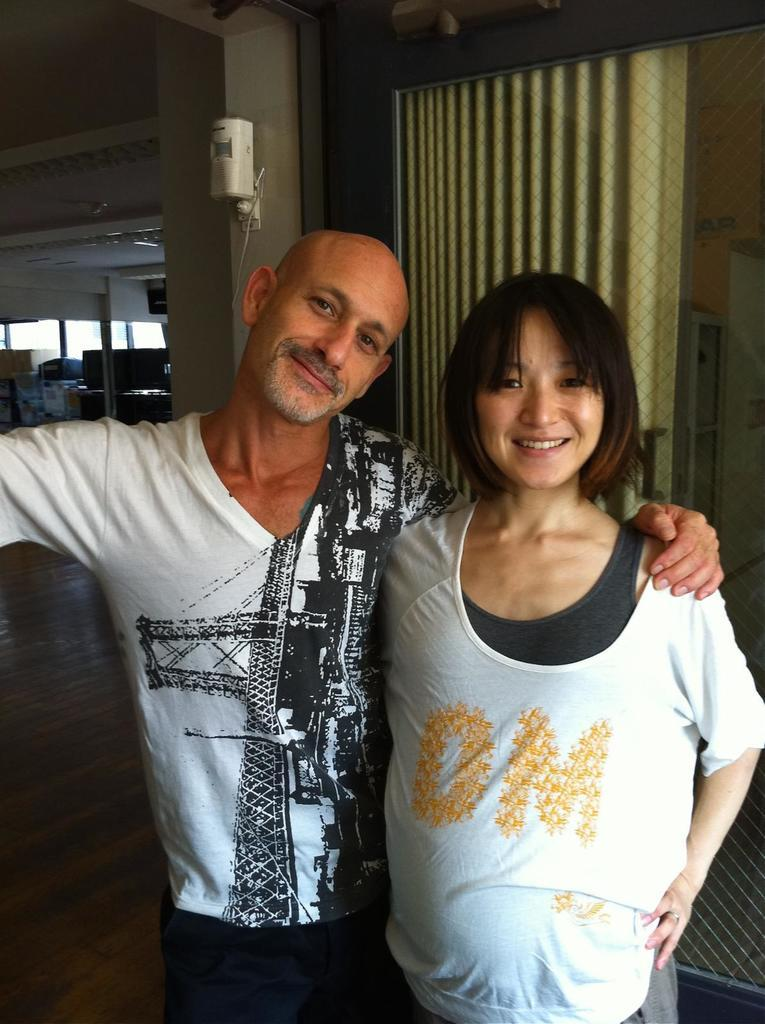How many people are present in the image? There are two people, a man and a woman, present in the image. What are the man and woman wearing? Both the man and woman are wearing white t-shirts. What can be seen in the background of the image? There is a curtain in the image. What color is the white object in the image? The white object in the image is white. How many sticks are being used by the man and woman in the image? There are no sticks present in the image; the man and woman are wearing white t-shirts and standing in front of a curtain. 